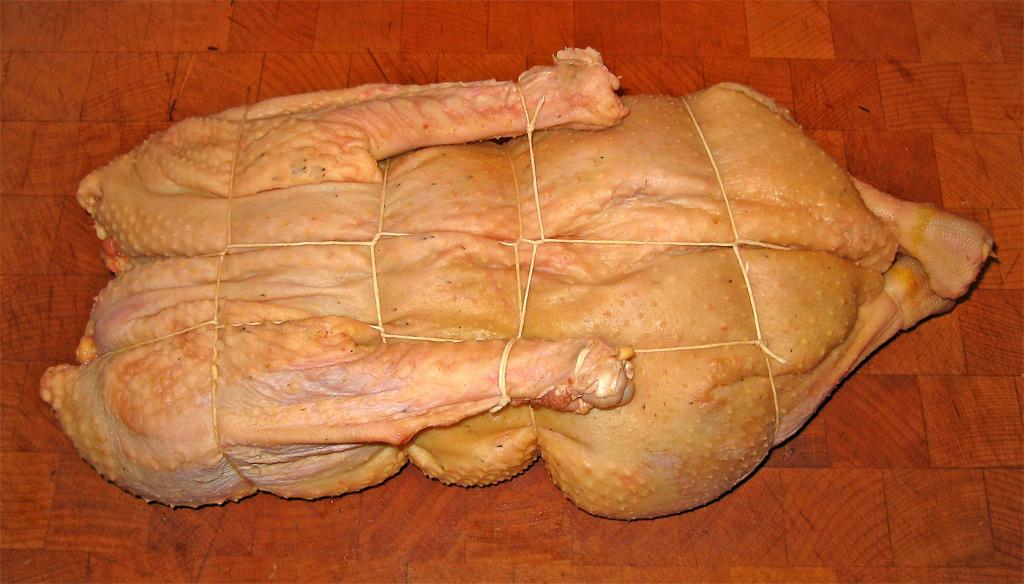What type of food is present in the image? There is meat in the image. How is the meat prepared or arranged? The meat is tied with threads. Where is the meat located in the image? The meat is placed on the floor. What mass of the meat can be seen in the image? The provided facts do not mention the mass of the meat, so it cannot be determined from the image. 